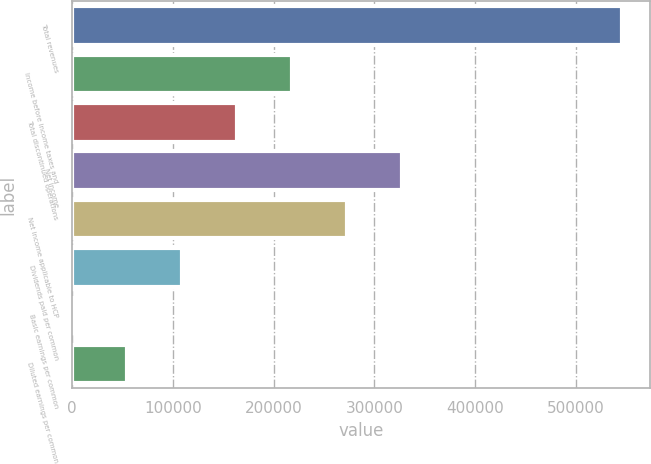Convert chart to OTSL. <chart><loc_0><loc_0><loc_500><loc_500><bar_chart><fcel>Total revenues<fcel>Income before income taxes and<fcel>Total discontinued operations<fcel>Net income<fcel>Net income applicable to HCP<fcel>Dividends paid per common<fcel>Basic earnings per common<fcel>Diluted earnings per common<nl><fcel>546158<fcel>218464<fcel>163848<fcel>327695<fcel>273079<fcel>109232<fcel>0.51<fcel>54616.3<nl></chart> 